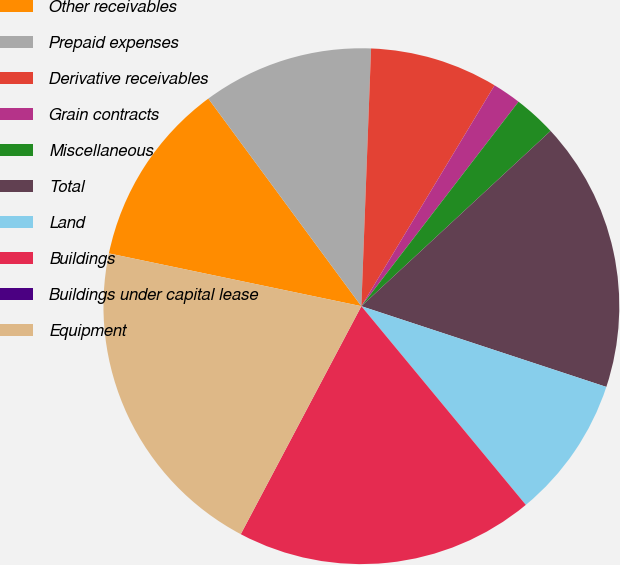Convert chart. <chart><loc_0><loc_0><loc_500><loc_500><pie_chart><fcel>Other receivables<fcel>Prepaid expenses<fcel>Derivative receivables<fcel>Grain contracts<fcel>Miscellaneous<fcel>Total<fcel>Land<fcel>Buildings<fcel>Buildings under capital lease<fcel>Equipment<nl><fcel>11.61%<fcel>10.71%<fcel>8.04%<fcel>1.79%<fcel>2.68%<fcel>16.96%<fcel>8.93%<fcel>18.75%<fcel>0.0%<fcel>20.54%<nl></chart> 